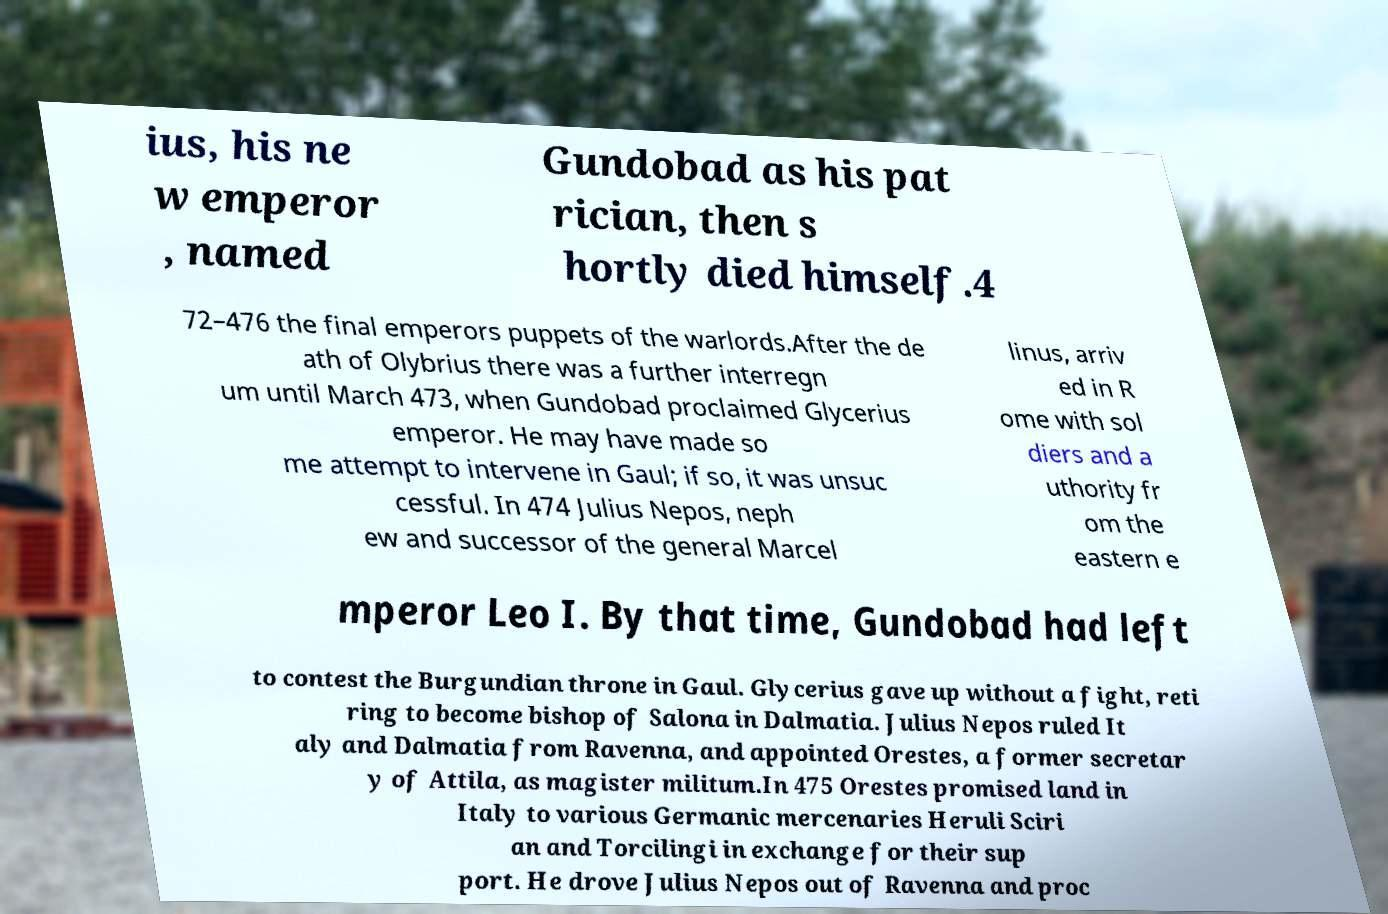What messages or text are displayed in this image? I need them in a readable, typed format. ius, his ne w emperor , named Gundobad as his pat rician, then s hortly died himself.4 72–476 the final emperors puppets of the warlords.After the de ath of Olybrius there was a further interregn um until March 473, when Gundobad proclaimed Glycerius emperor. He may have made so me attempt to intervene in Gaul; if so, it was unsuc cessful. In 474 Julius Nepos, neph ew and successor of the general Marcel linus, arriv ed in R ome with sol diers and a uthority fr om the eastern e mperor Leo I. By that time, Gundobad had left to contest the Burgundian throne in Gaul. Glycerius gave up without a fight, reti ring to become bishop of Salona in Dalmatia. Julius Nepos ruled It aly and Dalmatia from Ravenna, and appointed Orestes, a former secretar y of Attila, as magister militum.In 475 Orestes promised land in Italy to various Germanic mercenaries Heruli Sciri an and Torcilingi in exchange for their sup port. He drove Julius Nepos out of Ravenna and proc 